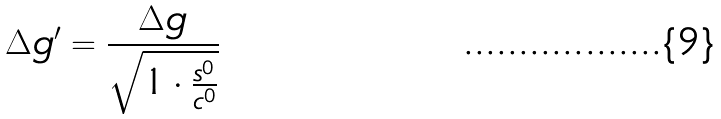Convert formula to latex. <formula><loc_0><loc_0><loc_500><loc_500>\Delta g ^ { \prime } = \frac { \Delta g } { \sqrt { 1 \cdot \frac { s ^ { 0 } } { c ^ { 0 } } } }</formula> 